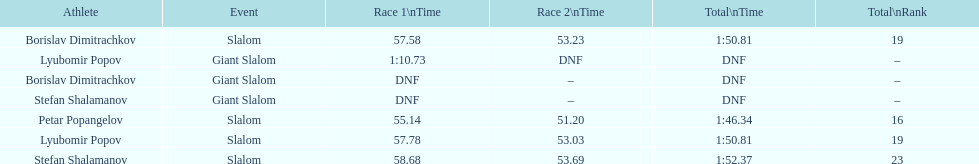How many athletes are there total? 4. 